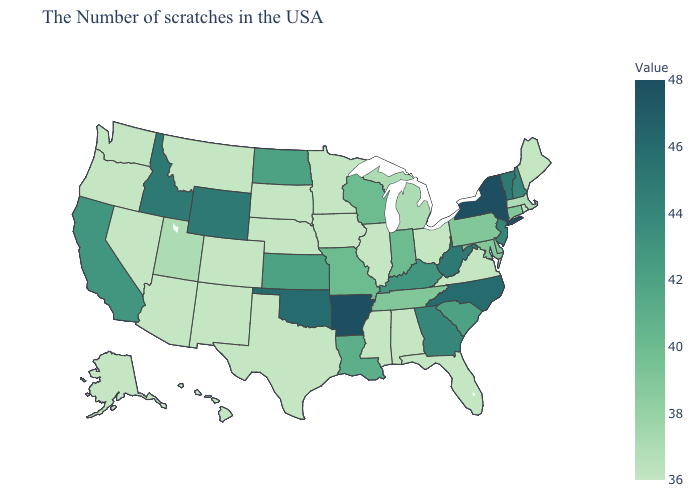Which states have the highest value in the USA?
Be succinct. New York, Arkansas. Which states have the lowest value in the USA?
Concise answer only. Maine, Rhode Island, Virginia, Ohio, Florida, Alabama, Illinois, Mississippi, Minnesota, Iowa, Nebraska, Texas, South Dakota, Colorado, New Mexico, Montana, Arizona, Nevada, Washington, Oregon, Alaska, Hawaii. Among the states that border Rhode Island , does Connecticut have the lowest value?
Short answer required. No. Does the map have missing data?
Short answer required. No. Among the states that border Kansas , does Missouri have the lowest value?
Give a very brief answer. No. Which states hav the highest value in the Northeast?
Be succinct. New York. Which states have the highest value in the USA?
Write a very short answer. New York, Arkansas. 